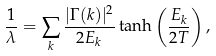Convert formula to latex. <formula><loc_0><loc_0><loc_500><loc_500>\frac { 1 } { \lambda } = \sum _ { k } \frac { | \Gamma ( { k } ) | ^ { 2 } } { 2 E _ { k } } \tanh \left ( \frac { E _ { k } } { 2 T } \right ) ,</formula> 